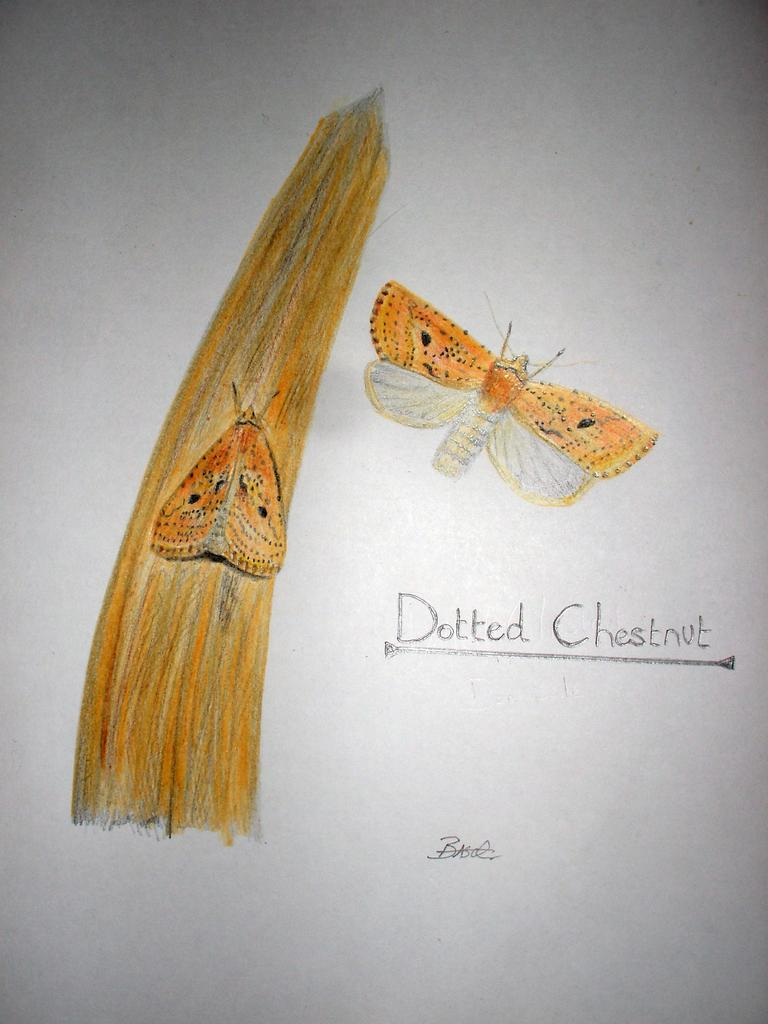What is depicted in the picture? There are sketches of two butterflies in the picture. Can you describe the text below the butterflies on the right side? The text "dotted chestnut" is written below the butterflies on the right side. Reasoning: Leting: Let's think step by step in order to produce the conversation. We start by identifying the main subjects in the image, which are the sketches of two butterflies. Then, we expand the conversation to include the text below the butterflies on the right side, which provides additional information about the butterflies. Each question is designed to elicit a specific detail about the image that is known from the provided facts. Absurd Question/Answer: What caused the butterflies to lose their wings in the image? There is no indication in the image that the butterflies have lost their wings or that there was any cause for it. 